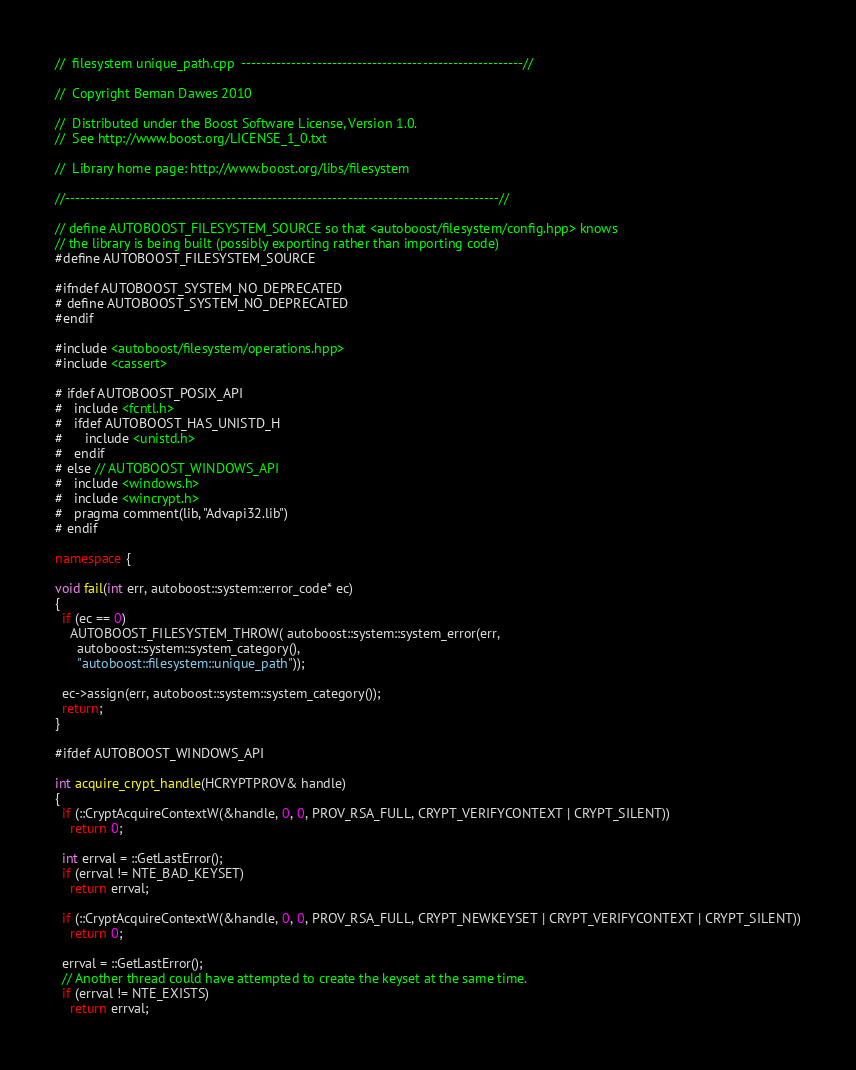<code> <loc_0><loc_0><loc_500><loc_500><_C++_>//  filesystem unique_path.cpp  --------------------------------------------------------//

//  Copyright Beman Dawes 2010

//  Distributed under the Boost Software License, Version 1.0.
//  See http://www.boost.org/LICENSE_1_0.txt

//  Library home page: http://www.boost.org/libs/filesystem

//--------------------------------------------------------------------------------------//

// define AUTOBOOST_FILESYSTEM_SOURCE so that <autoboost/filesystem/config.hpp> knows
// the library is being built (possibly exporting rather than importing code)
#define AUTOBOOST_FILESYSTEM_SOURCE

#ifndef AUTOBOOST_SYSTEM_NO_DEPRECATED
# define AUTOBOOST_SYSTEM_NO_DEPRECATED
#endif

#include <autoboost/filesystem/operations.hpp>
#include <cassert>

# ifdef AUTOBOOST_POSIX_API
#   include <fcntl.h>
#   ifdef AUTOBOOST_HAS_UNISTD_H
#      include <unistd.h>
#   endif
# else // AUTOBOOST_WINDOWS_API
#   include <windows.h>
#   include <wincrypt.h>
#   pragma comment(lib, "Advapi32.lib")
# endif

namespace {

void fail(int err, autoboost::system::error_code* ec)
{
  if (ec == 0)
    AUTOBOOST_FILESYSTEM_THROW( autoboost::system::system_error(err,
      autoboost::system::system_category(),
      "autoboost::filesystem::unique_path"));

  ec->assign(err, autoboost::system::system_category());
  return;
}

#ifdef AUTOBOOST_WINDOWS_API

int acquire_crypt_handle(HCRYPTPROV& handle)
{
  if (::CryptAcquireContextW(&handle, 0, 0, PROV_RSA_FULL, CRYPT_VERIFYCONTEXT | CRYPT_SILENT))
    return 0;

  int errval = ::GetLastError();
  if (errval != NTE_BAD_KEYSET)
    return errval;

  if (::CryptAcquireContextW(&handle, 0, 0, PROV_RSA_FULL, CRYPT_NEWKEYSET | CRYPT_VERIFYCONTEXT | CRYPT_SILENT))
    return 0;

  errval = ::GetLastError();
  // Another thread could have attempted to create the keyset at the same time.
  if (errval != NTE_EXISTS)
    return errval;
</code> 